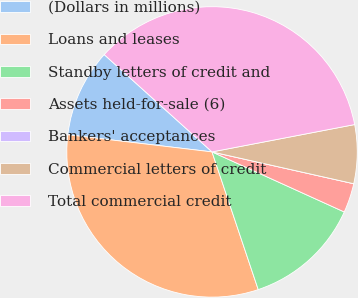<chart> <loc_0><loc_0><loc_500><loc_500><pie_chart><fcel>(Dollars in millions)<fcel>Loans and leases<fcel>Standby letters of credit and<fcel>Assets held-for-sale (6)<fcel>Bankers' acceptances<fcel>Commercial letters of credit<fcel>Total commercial credit<nl><fcel>9.8%<fcel>32.04%<fcel>13.06%<fcel>3.27%<fcel>0.0%<fcel>6.53%<fcel>35.3%<nl></chart> 